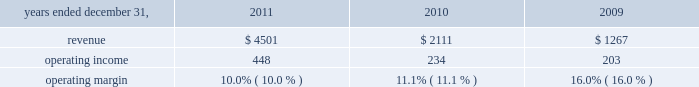Reinsurance commissions , fees and other revenue increased 1% ( 1 % ) driven by a favorable foreign currency translation of 2% ( 2 % ) and was partially offset by a 1% ( 1 % ) decline in dispositions , net of acquisitions and other .
Organic revenue was flat primarily resulting from strong growth in the capital market transactions and advisory business , partially offset by declines in global facultative placements .
Operating income operating income increased $ 120 million , or 10% ( 10 % ) , from 2010 to $ 1.3 billion in 2011 .
In 2011 , operating income margins in this segment were 19.3% ( 19.3 % ) , up 70 basis points from 18.6% ( 18.6 % ) in 2010 .
Operating margin improvement was primarily driven by revenue growth , reduced costs of restructuring initiatives and realization of the benefits of those restructuring plans , which was partially offset by the negative impact of expense increases related to investment in the business , lease termination costs , legacy receivables write-off , and foreign currency exchange rates .
Hr solutions .
In october 2010 , we completed the acquisition of hewitt , one of the world 2019s leading human resource consulting and outsourcing companies .
Hewitt operates globally together with aon 2019s existing consulting and outsourcing operations under the newly created aon hewitt brand .
Hewitt 2019s operating results are included in aon 2019s results of operations beginning october 1 , 2010 .
Our hr solutions segment generated approximately 40% ( 40 % ) of our consolidated total revenues in 2011 and provides a broad range of human capital services , as follows : 2022 health and benefits advises clients about how to structure , fund , and administer employee benefit programs that attract , retain , and motivate employees .
Benefits consulting includes health and welfare , executive benefits , workforce strategies and productivity , absence management , benefits administration , data-driven health , compliance , employee commitment , investment advisory and elective benefits services .
Effective january 1 , 2012 , this line of business will be included in the results of the risk solutions segment .
2022 retirement specializes in global actuarial services , defined contribution consulting , investment consulting , tax and erisa consulting , and pension administration .
2022 compensation focuses on compensatory advisory/counsel including : compensation planning design , executive reward strategies , salary survey and benchmarking , market share studies and sales force effectiveness , with special expertise in the financial services and technology industries .
2022 strategic human capital delivers advice to complex global organizations on talent , change and organizational effectiveness issues , including talent strategy and acquisition , executive on-boarding , performance management , leadership assessment and development , communication strategy , workforce training and change management .
2022 benefits administration applies our hr expertise primarily through defined benefit ( pension ) , defined contribution ( 401 ( k ) ) , and health and welfare administrative services .
Our model replaces the resource-intensive processes once required to administer benefit plans with more efficient , effective , and less costly solutions .
2022 human resource business processing outsourcing ( 2018 2018hr bpo 2019 2019 ) provides market-leading solutions to manage employee data ; administer benefits , payroll and other human resources processes ; and .
What is the highest revenue observed in this period? 
Rationale: it is the maximum value .
Computations: table_min(revenue, none)
Answer: 1267.0. Reinsurance commissions , fees and other revenue increased 1% ( 1 % ) driven by a favorable foreign currency translation of 2% ( 2 % ) and was partially offset by a 1% ( 1 % ) decline in dispositions , net of acquisitions and other .
Organic revenue was flat primarily resulting from strong growth in the capital market transactions and advisory business , partially offset by declines in global facultative placements .
Operating income operating income increased $ 120 million , or 10% ( 10 % ) , from 2010 to $ 1.3 billion in 2011 .
In 2011 , operating income margins in this segment were 19.3% ( 19.3 % ) , up 70 basis points from 18.6% ( 18.6 % ) in 2010 .
Operating margin improvement was primarily driven by revenue growth , reduced costs of restructuring initiatives and realization of the benefits of those restructuring plans , which was partially offset by the negative impact of expense increases related to investment in the business , lease termination costs , legacy receivables write-off , and foreign currency exchange rates .
Hr solutions .
In october 2010 , we completed the acquisition of hewitt , one of the world 2019s leading human resource consulting and outsourcing companies .
Hewitt operates globally together with aon 2019s existing consulting and outsourcing operations under the newly created aon hewitt brand .
Hewitt 2019s operating results are included in aon 2019s results of operations beginning october 1 , 2010 .
Our hr solutions segment generated approximately 40% ( 40 % ) of our consolidated total revenues in 2011 and provides a broad range of human capital services , as follows : 2022 health and benefits advises clients about how to structure , fund , and administer employee benefit programs that attract , retain , and motivate employees .
Benefits consulting includes health and welfare , executive benefits , workforce strategies and productivity , absence management , benefits administration , data-driven health , compliance , employee commitment , investment advisory and elective benefits services .
Effective january 1 , 2012 , this line of business will be included in the results of the risk solutions segment .
2022 retirement specializes in global actuarial services , defined contribution consulting , investment consulting , tax and erisa consulting , and pension administration .
2022 compensation focuses on compensatory advisory/counsel including : compensation planning design , executive reward strategies , salary survey and benchmarking , market share studies and sales force effectiveness , with special expertise in the financial services and technology industries .
2022 strategic human capital delivers advice to complex global organizations on talent , change and organizational effectiveness issues , including talent strategy and acquisition , executive on-boarding , performance management , leadership assessment and development , communication strategy , workforce training and change management .
2022 benefits administration applies our hr expertise primarily through defined benefit ( pension ) , defined contribution ( 401 ( k ) ) , and health and welfare administrative services .
Our model replaces the resource-intensive processes once required to administer benefit plans with more efficient , effective , and less costly solutions .
2022 human resource business processing outsourcing ( 2018 2018hr bpo 2019 2019 ) provides market-leading solutions to manage employee data ; administer benefits , payroll and other human resources processes ; and .
What is the average operating income? 
Rationale: it is the sum of all operating income divided by three .
Computations: table_average(operating income, none)
Answer: 295.0. Reinsurance commissions , fees and other revenue increased 1% ( 1 % ) driven by a favorable foreign currency translation of 2% ( 2 % ) and was partially offset by a 1% ( 1 % ) decline in dispositions , net of acquisitions and other .
Organic revenue was flat primarily resulting from strong growth in the capital market transactions and advisory business , partially offset by declines in global facultative placements .
Operating income operating income increased $ 120 million , or 10% ( 10 % ) , from 2010 to $ 1.3 billion in 2011 .
In 2011 , operating income margins in this segment were 19.3% ( 19.3 % ) , up 70 basis points from 18.6% ( 18.6 % ) in 2010 .
Operating margin improvement was primarily driven by revenue growth , reduced costs of restructuring initiatives and realization of the benefits of those restructuring plans , which was partially offset by the negative impact of expense increases related to investment in the business , lease termination costs , legacy receivables write-off , and foreign currency exchange rates .
Hr solutions .
In october 2010 , we completed the acquisition of hewitt , one of the world 2019s leading human resource consulting and outsourcing companies .
Hewitt operates globally together with aon 2019s existing consulting and outsourcing operations under the newly created aon hewitt brand .
Hewitt 2019s operating results are included in aon 2019s results of operations beginning october 1 , 2010 .
Our hr solutions segment generated approximately 40% ( 40 % ) of our consolidated total revenues in 2011 and provides a broad range of human capital services , as follows : 2022 health and benefits advises clients about how to structure , fund , and administer employee benefit programs that attract , retain , and motivate employees .
Benefits consulting includes health and welfare , executive benefits , workforce strategies and productivity , absence management , benefits administration , data-driven health , compliance , employee commitment , investment advisory and elective benefits services .
Effective january 1 , 2012 , this line of business will be included in the results of the risk solutions segment .
2022 retirement specializes in global actuarial services , defined contribution consulting , investment consulting , tax and erisa consulting , and pension administration .
2022 compensation focuses on compensatory advisory/counsel including : compensation planning design , executive reward strategies , salary survey and benchmarking , market share studies and sales force effectiveness , with special expertise in the financial services and technology industries .
2022 strategic human capital delivers advice to complex global organizations on talent , change and organizational effectiveness issues , including talent strategy and acquisition , executive on-boarding , performance management , leadership assessment and development , communication strategy , workforce training and change management .
2022 benefits administration applies our hr expertise primarily through defined benefit ( pension ) , defined contribution ( 401 ( k ) ) , and health and welfare administrative services .
Our model replaces the resource-intensive processes once required to administer benefit plans with more efficient , effective , and less costly solutions .
2022 human resource business processing outsourcing ( 2018 2018hr bpo 2019 2019 ) provides market-leading solutions to manage employee data ; administer benefits , payroll and other human resources processes ; and .
What was the percent of the increase in the operating income from 2010 to 2011? 
Rationale: the operating income increased by 91.5% from 2010 to 2011
Computations: ((448 - 234) / 234)
Answer: 0.91453. 